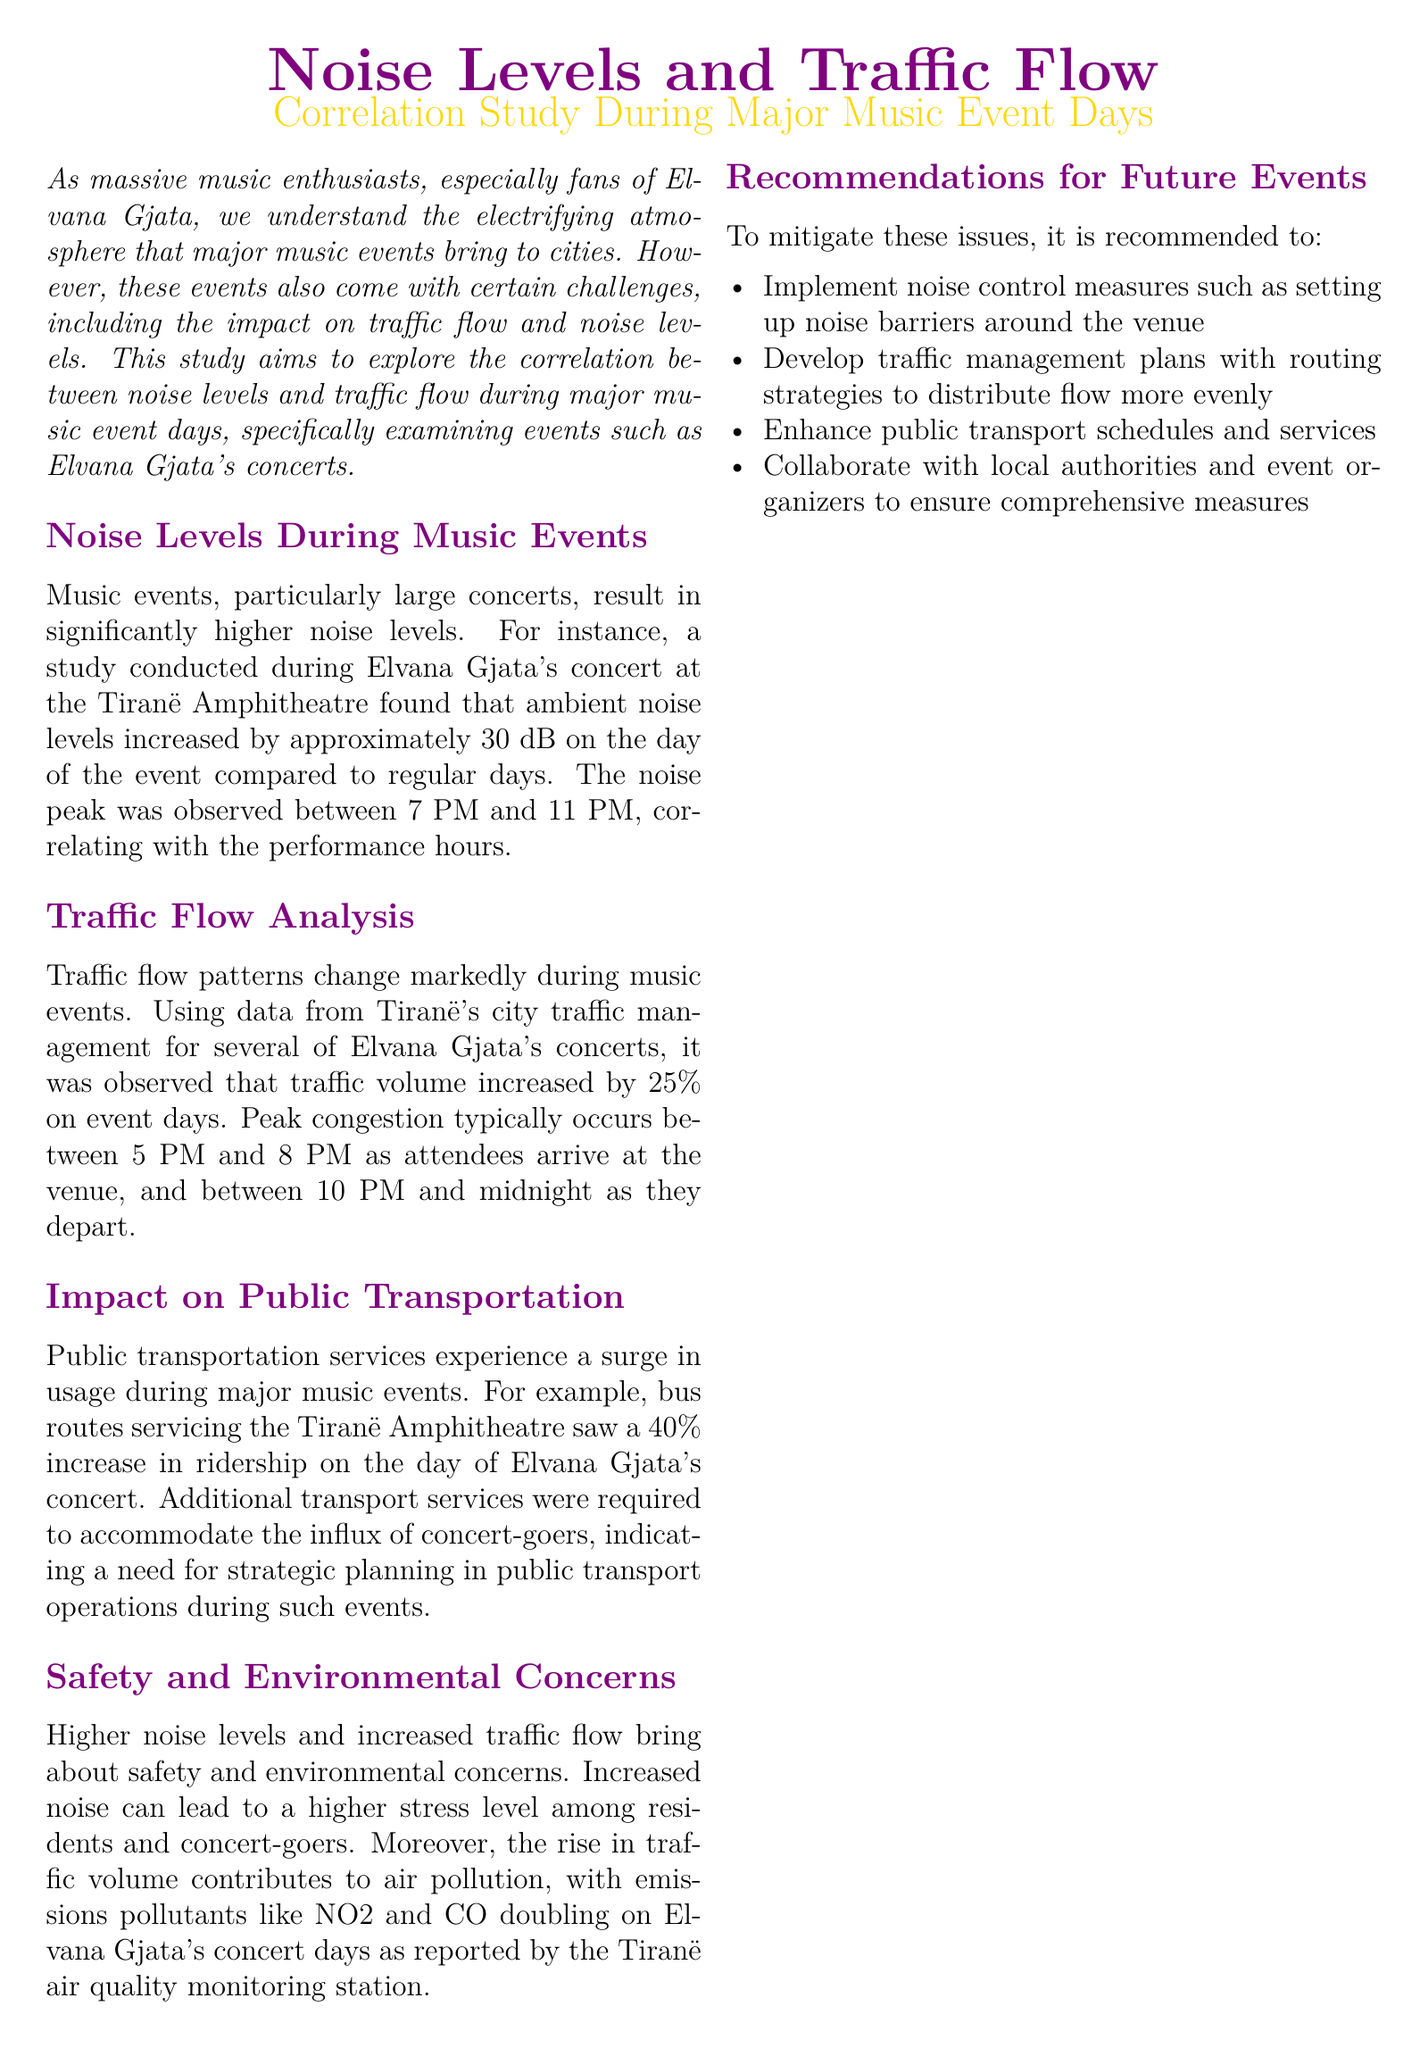what was the increase in ambient noise levels during Elvana Gjata's concert? The ambient noise levels increased by approximately 30 dB on the day of the event compared to regular days.
Answer: 30 dB what time frame saw peak noise levels during the concert? The peak noise levels were observed between 7 PM and 11 PM, correlating with the performance hours.
Answer: 7 PM to 11 PM by what percentage did traffic volume increase on event days? The study observed that traffic volume increased by 25% on event days.
Answer: 25% what percentage increase in public transport ridership was reported on concert day? The bus routes servicing the Tiranë Amphitheatre saw a 40% increase in ridership on the day of the concert.
Answer: 40% what emissions pollutants doubled on Elvana Gjata's concert days? The emissions pollutants like NO2 and CO doubled on concert days.
Answer: NO2 and CO what are two recommended noise control measures mentioned? Implement noise control measures such as setting up noise barriers around the venue is recommended.
Answer: noise barriers during which time do attendees typically arrive at the venue? Peak congestion typically occurs between 5 PM and 8 PM as attendees arrive at the venue.
Answer: 5 PM to 8 PM which venue is specifically mentioned in connection with Elvana Gjata's concerts? The Tiranë Amphitheatre is the venue mentioned in the report regarding her concerts.
Answer: Tiranë Amphitheatre what factor contributes to air pollution during music events? The rise in traffic volume contributes to air pollution.
Answer: traffic volume 